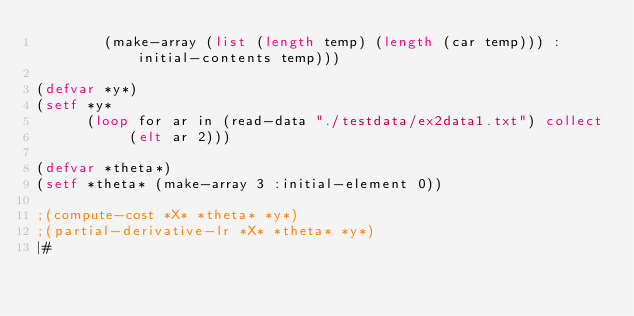<code> <loc_0><loc_0><loc_500><loc_500><_Lisp_>        (make-array (list (length temp) (length (car temp))) :initial-contents temp)))

(defvar *y*)
(setf *y*
      (loop for ar in (read-data "./testdata/ex2data1.txt") collect
           (elt ar 2)))

(defvar *theta*)
(setf *theta* (make-array 3 :initial-element 0))

;(compute-cost *X* *theta* *y*)
;(partial-derivative-lr *X* *theta* *y*)
|#
</code> 